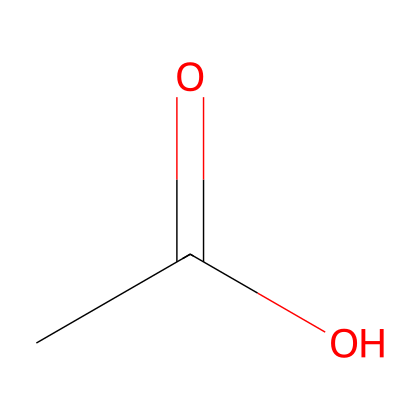What is the chemical name of the compound represented? The SMILES notation 'CC(=O)O' corresponds to acetic acid, which is recognized for its carboxylic acid functional group and is commonly used in various applications, including preserving wood.
Answer: acetic acid How many carbon atoms are in this compound? The structure 'CC(=O)O' indicates that there are two carbon atoms present; one in the CH3 group and one in the COOH group.
Answer: 2 What type of functional group is present in this chemical structure? The notation 'C(=O)O' signifies a carboxylic acid functional group, which is characterized by a carbon atom double-bonded to an oxygen atom and also bonded to a hydroxyl group (-OH).
Answer: carboxylic acid How many hydrogen atoms are in acetic acid? When analyzing 'CC(=O)O', it has four hydrogen atoms in total: three from the methyl group (CH3) and one from the hydroxyl part (-OH).
Answer: 4 Which part of the chemical structure contributes to its acidic properties? The -COOH part of 'CC(=O)O' is responsible for its acidity because it can donate a proton (H+), thus characterizing it as an acid.
Answer: -COOH What is the total number of oxygen atoms in this structure? In the SMILES 'CC(=O)O', there are two oxygen atoms: one in the carbonyl (C=O) and one in the hydroxyl (-OH) group.
Answer: 2 